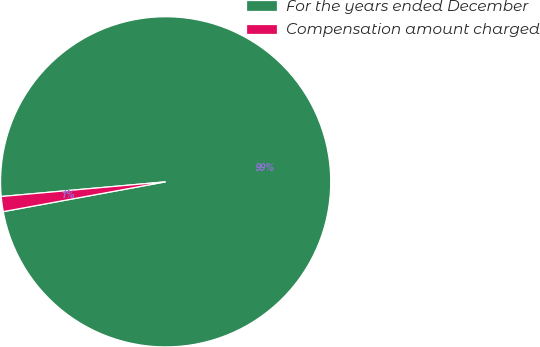Convert chart to OTSL. <chart><loc_0><loc_0><loc_500><loc_500><pie_chart><fcel>For the years ended December<fcel>Compensation amount charged<nl><fcel>98.53%<fcel>1.47%<nl></chart> 